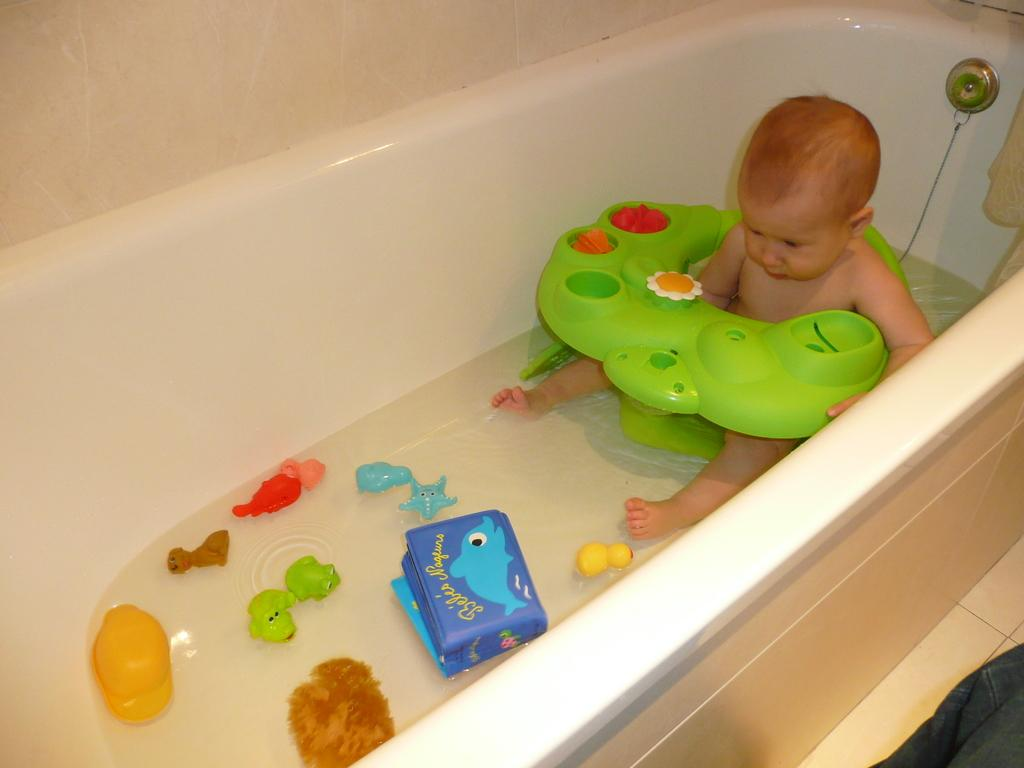What is the main subject of the image? There is a child in the image. What else can be seen in the image besides the child? There are toys and water in a bathtub in the image. Are there any other objects present in the image? Yes, there are objects in the image. What can be seen in the background of the image? There is a wall visible in the background of the image. How much does the fold of the child's towel cost in the image? There is no fold of a towel or any mention of cost in the image. 